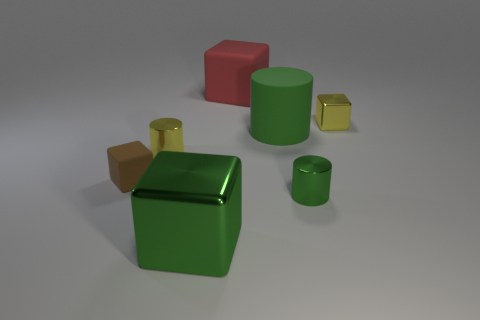Subtract 1 blocks. How many blocks are left? 3 Add 1 small purple shiny things. How many objects exist? 8 Subtract all blocks. How many objects are left? 3 Subtract 0 purple blocks. How many objects are left? 7 Subtract all large green matte cylinders. Subtract all big gray metal cylinders. How many objects are left? 6 Add 7 tiny metal things. How many tiny metal things are left? 10 Add 4 matte cylinders. How many matte cylinders exist? 5 